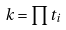Convert formula to latex. <formula><loc_0><loc_0><loc_500><loc_500>k = \prod t _ { i }</formula> 